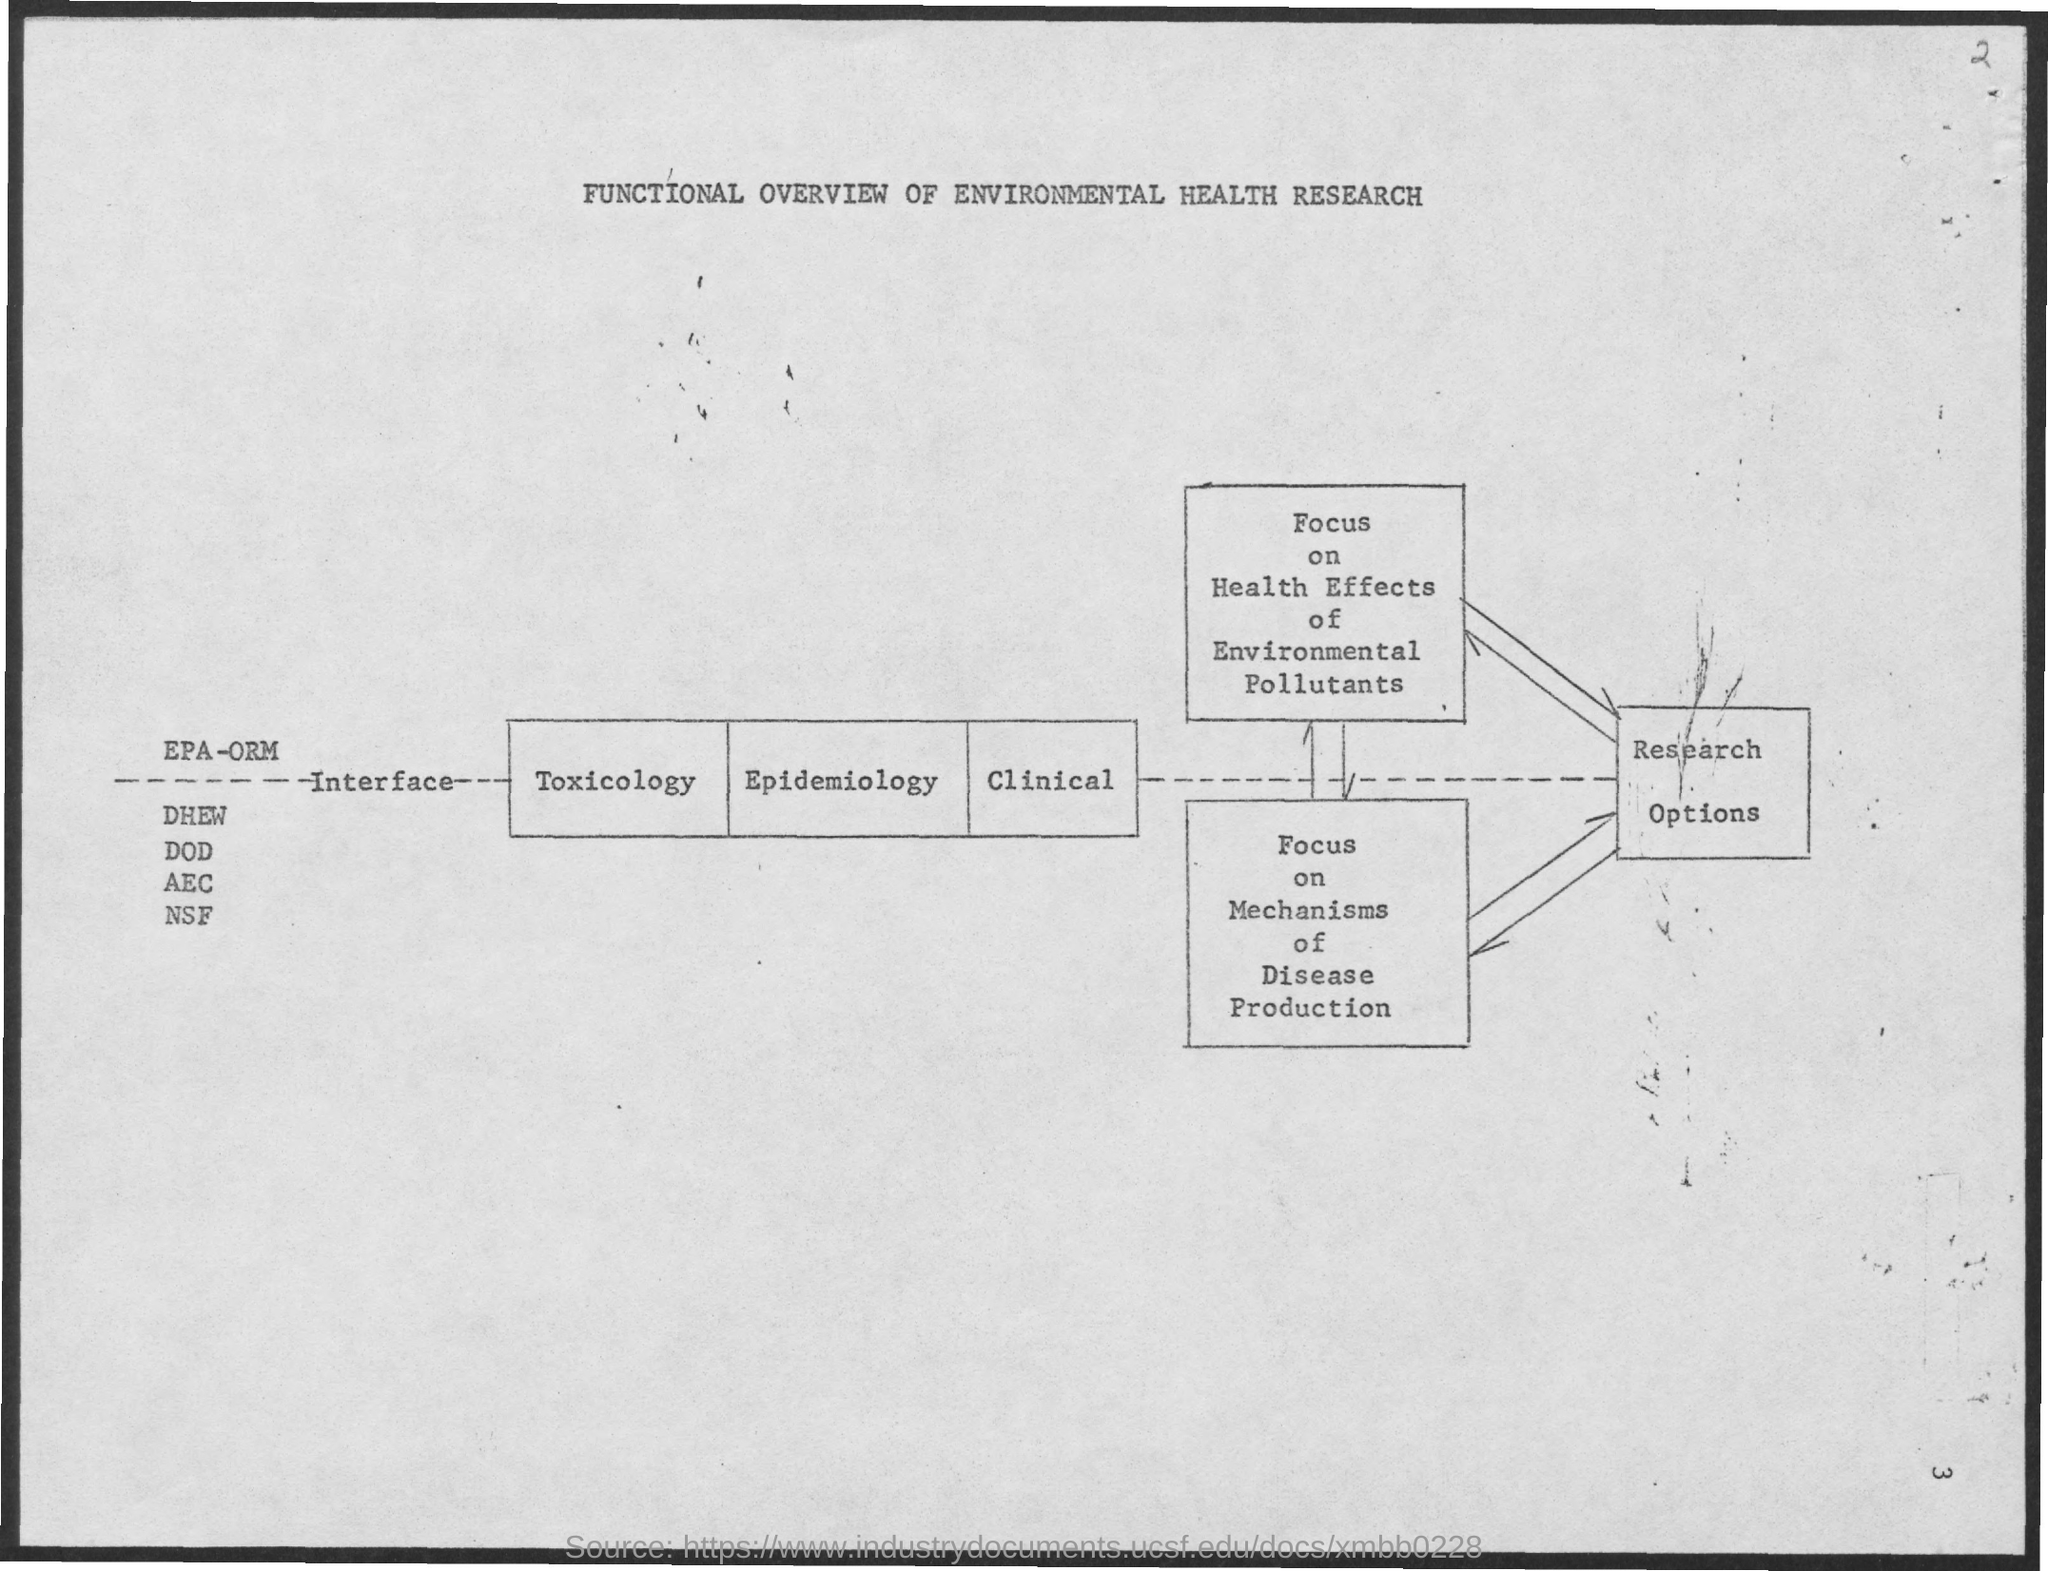Specify some key components in this picture. The document in question is titled 'Functional Overview of Environmental Health Research.' 